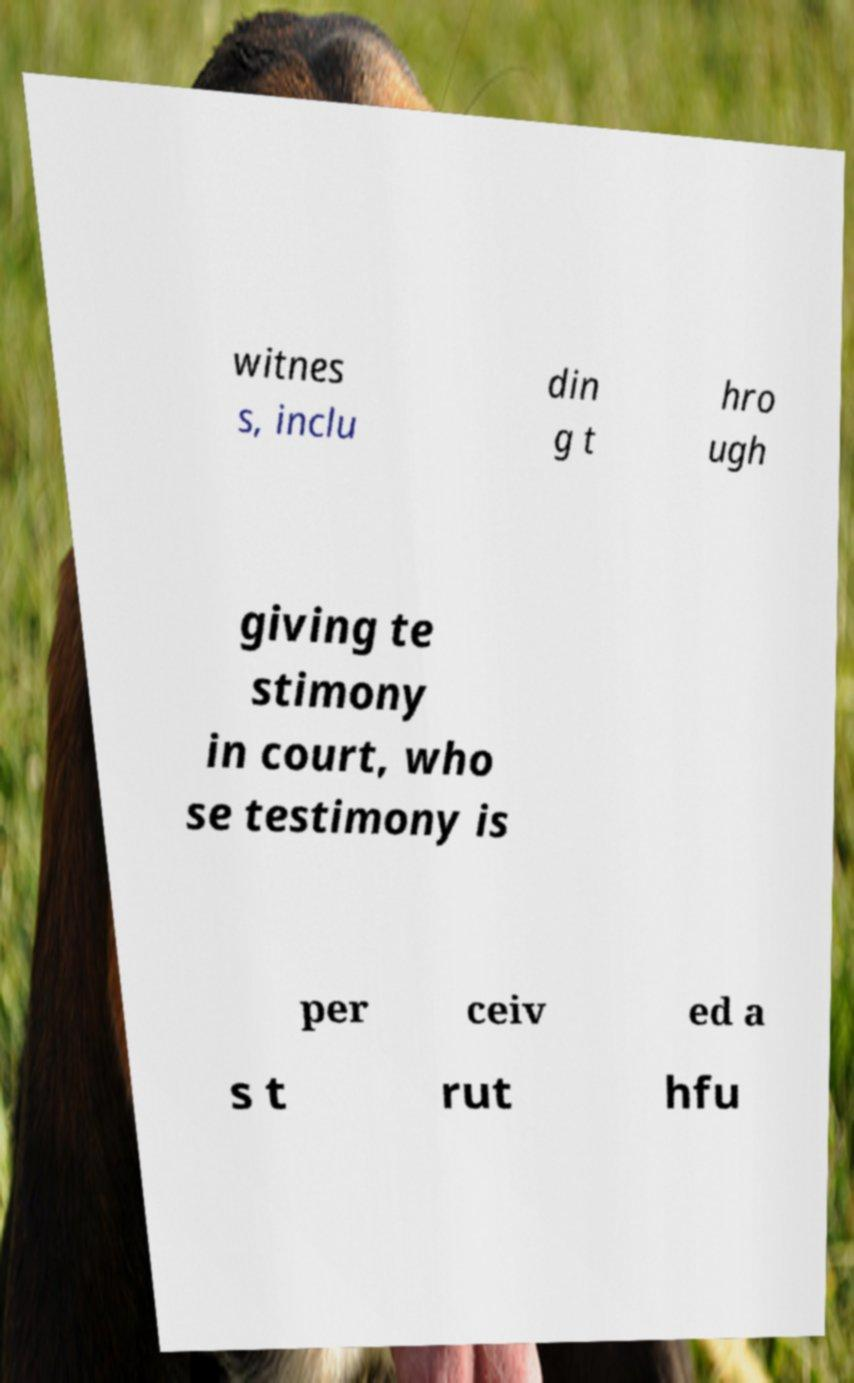I need the written content from this picture converted into text. Can you do that? witnes s, inclu din g t hro ugh giving te stimony in court, who se testimony is per ceiv ed a s t rut hfu 